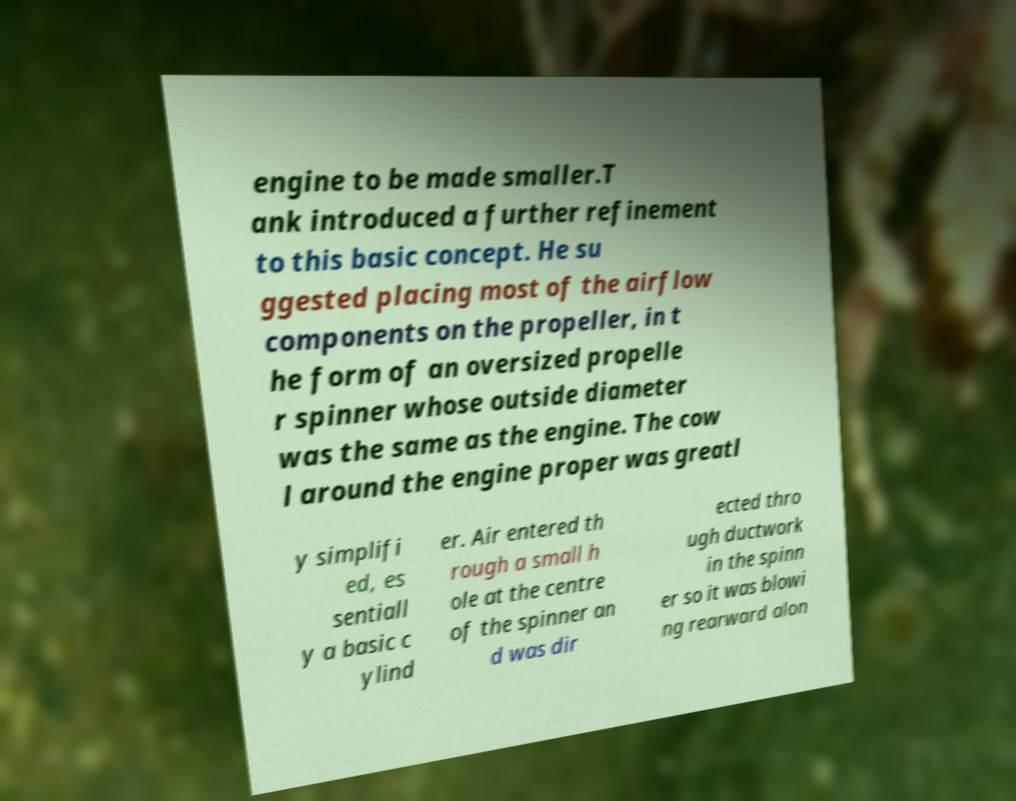Can you read and provide the text displayed in the image?This photo seems to have some interesting text. Can you extract and type it out for me? engine to be made smaller.T ank introduced a further refinement to this basic concept. He su ggested placing most of the airflow components on the propeller, in t he form of an oversized propelle r spinner whose outside diameter was the same as the engine. The cow l around the engine proper was greatl y simplifi ed, es sentiall y a basic c ylind er. Air entered th rough a small h ole at the centre of the spinner an d was dir ected thro ugh ductwork in the spinn er so it was blowi ng rearward alon 